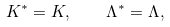Convert formula to latex. <formula><loc_0><loc_0><loc_500><loc_500>K ^ { \ast } = K , \quad \Lambda ^ { \ast } = { \Lambda } ,</formula> 